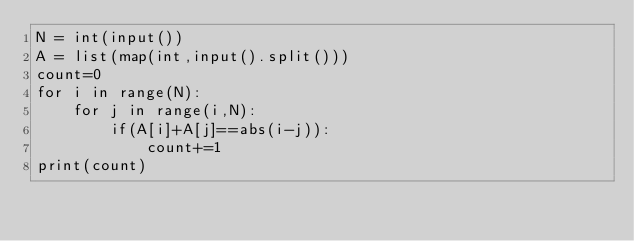<code> <loc_0><loc_0><loc_500><loc_500><_Python_>N = int(input())
A = list(map(int,input().split()))
count=0
for i in range(N):
    for j in range(i,N):
        if(A[i]+A[j]==abs(i-j)):
            count+=1
print(count)
</code> 